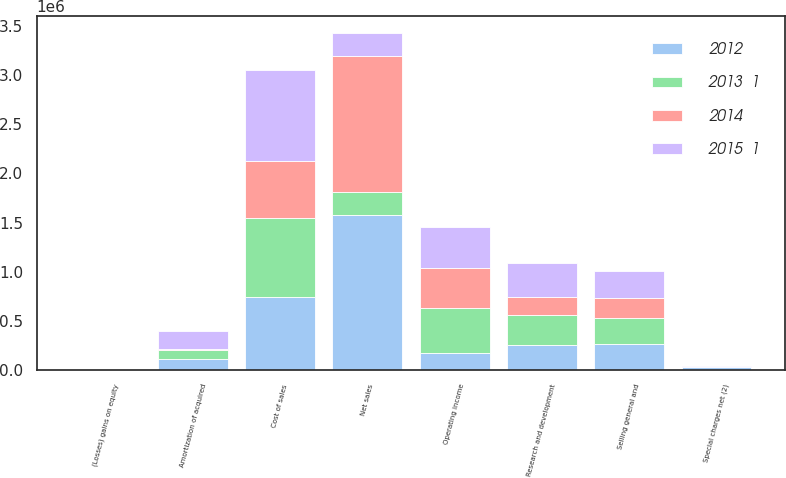Convert chart to OTSL. <chart><loc_0><loc_0><loc_500><loc_500><stacked_bar_chart><ecel><fcel>Net sales<fcel>Cost of sales<fcel>Research and development<fcel>Selling general and<fcel>Amortization of acquired<fcel>Special charges net (2)<fcel>Operating income<fcel>(Losses) gains on equity<nl><fcel>2015  1<fcel>231526<fcel>917472<fcel>349543<fcel>274815<fcel>176746<fcel>2840<fcel>425620<fcel>317<nl><fcel>2013  1<fcel>231526<fcel>802474<fcel>305043<fcel>267278<fcel>94534<fcel>3024<fcel>458864<fcel>177<nl><fcel>2012<fcel>1.58162e+06<fcel>743164<fcel>254723<fcel>261471<fcel>111537<fcel>32175<fcel>178553<fcel>617<nl><fcel>2014<fcel>1.38318e+06<fcel>583882<fcel>182650<fcel>208328<fcel>10963<fcel>837<fcel>396516<fcel>195<nl></chart> 